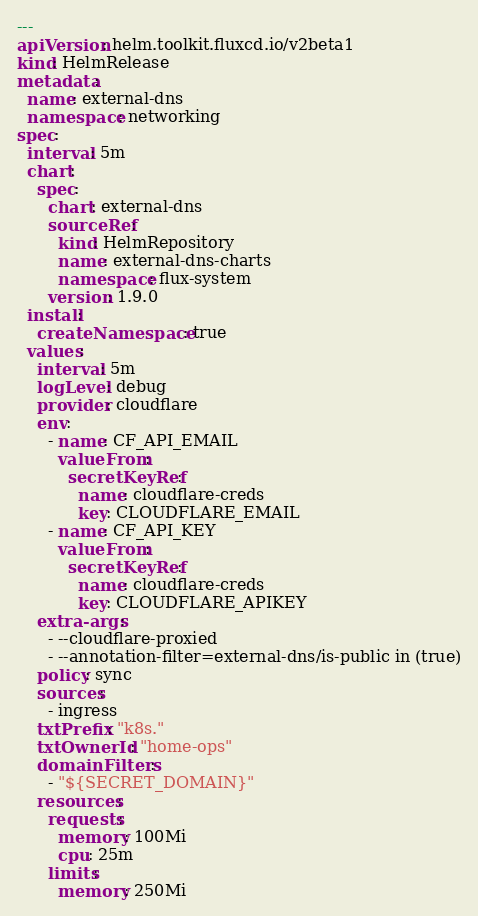Convert code to text. <code><loc_0><loc_0><loc_500><loc_500><_YAML_>---
apiVersion: helm.toolkit.fluxcd.io/v2beta1
kind: HelmRelease
metadata:
  name: external-dns
  namespace: networking
spec:
  interval: 5m
  chart:
    spec:
      chart: external-dns
      sourceRef:
        kind: HelmRepository
        name: external-dns-charts
        namespace: flux-system
      version: 1.9.0
  install:
    createNamespace: true
  values:
    interval: 5m
    logLevel: debug
    provider: cloudflare
    env:
      - name: CF_API_EMAIL
        valueFrom:
          secretKeyRef:
            name: cloudflare-creds
            key: CLOUDFLARE_EMAIL
      - name: CF_API_KEY
        valueFrom:
          secretKeyRef:
            name: cloudflare-creds
            key: CLOUDFLARE_APIKEY
    extra-args:
      - --cloudflare-proxied
      - --annotation-filter=external-dns/is-public in (true)
    policy: sync
    sources:
      - ingress
    txtPrefix: "k8s."
    txtOwnerId: "home-ops"
    domainFilters:
      - "${SECRET_DOMAIN}"
    resources:
      requests:
        memory: 100Mi
        cpu: 25m
      limits:
        memory: 250Mi
</code> 